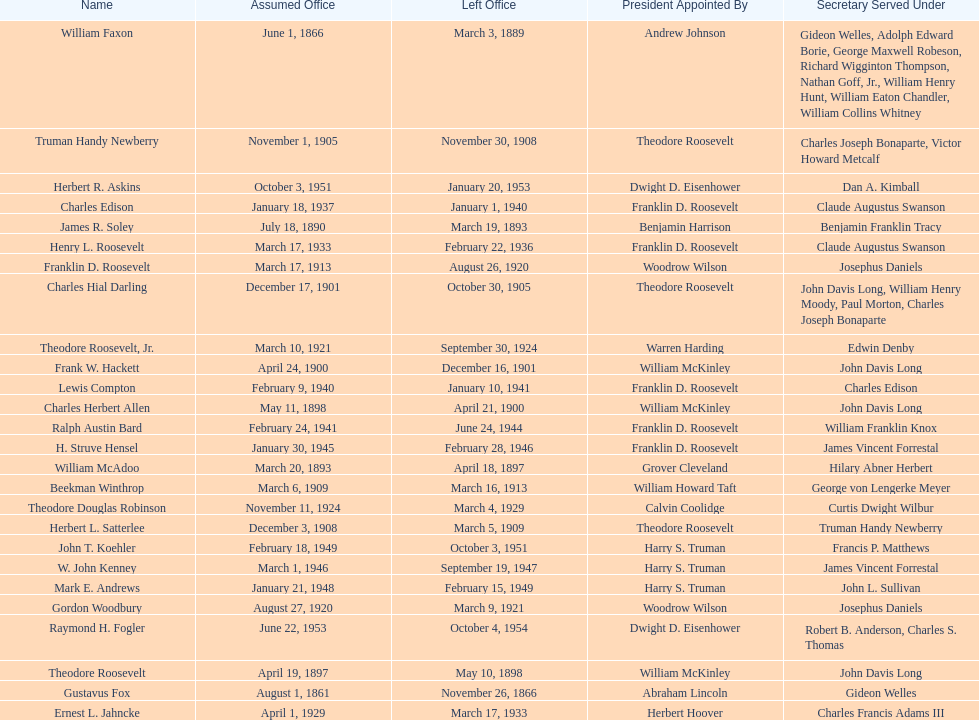When did raymond h. fogler leave the office of assistant secretary of the navy? October 4, 1954. 